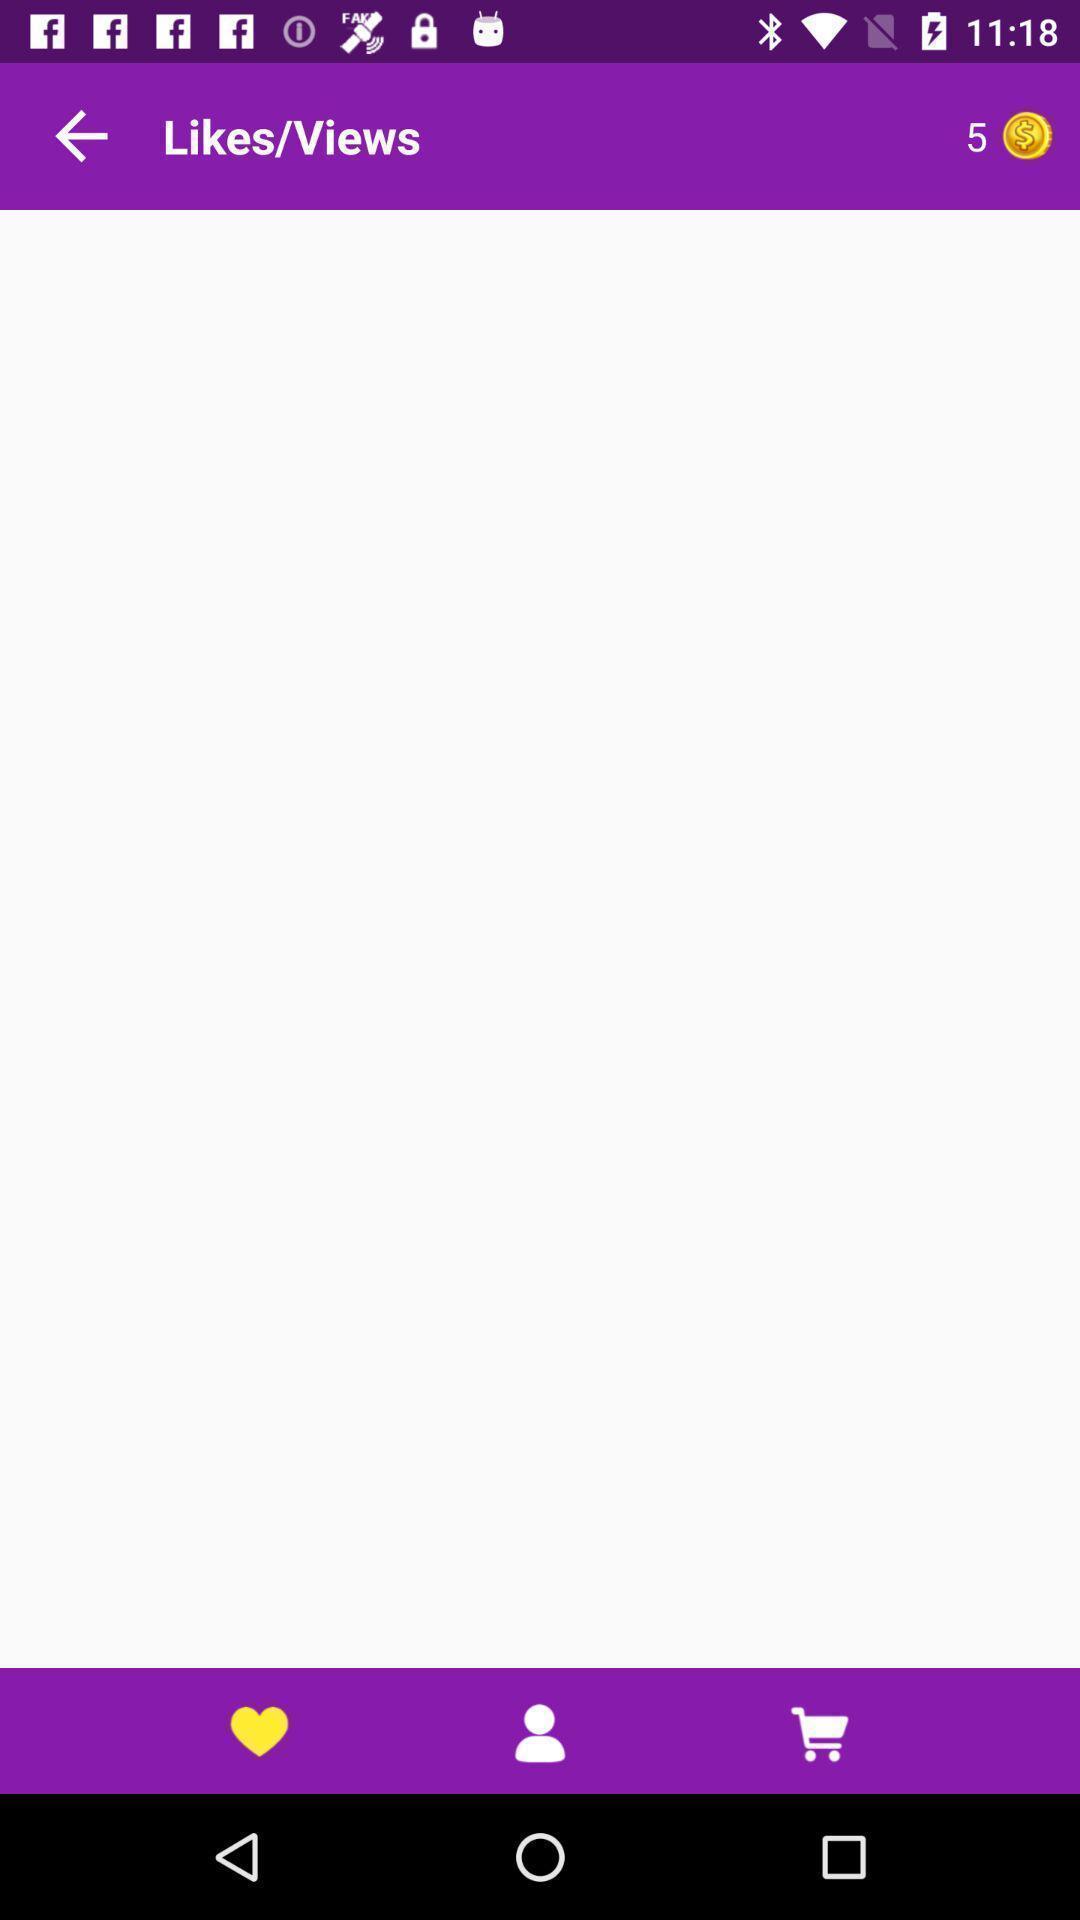Describe the key features of this screenshot. Page for viewing likes and views of a shopping app. 